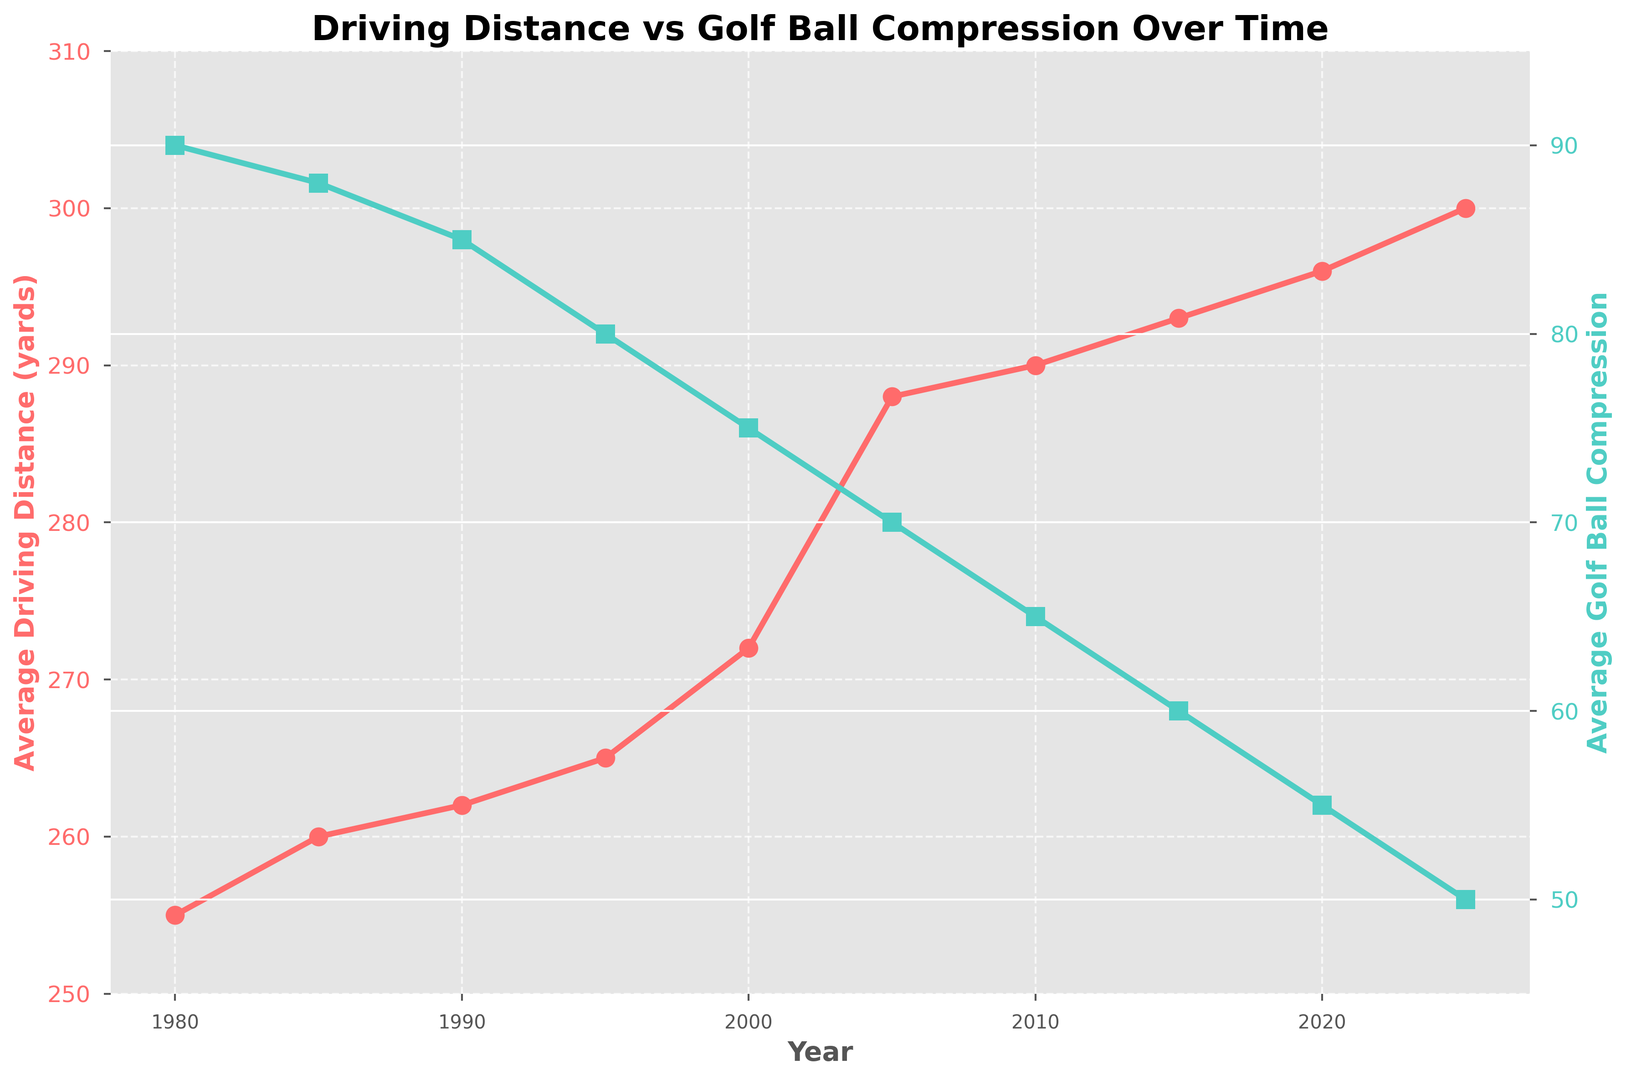What is the trend in average driving distance from 1980 to 2025? The figure shows a line plot of the average driving distance over the years. Observing the slope of the line, the driving distance consistently increases from 255 yards in 1980 to 300 yards in 2025.
Answer: Increasing What is the difference in average golf ball compression between 1980 and 2025? In 1980, the average golf ball compression is 90, and in 2025, it is 50. The difference can be calculated as 90 - 50.
Answer: 40 Which year shows the steepest increase in average driving distance? By examining the slope of the driving distance line, the steepest increase appears between 2000 and 2005, where the slope is the steepest.
Answer: 2000-2005 How does the average golf ball compression trend over time? The plot shows that the average golf ball compression decreases over time, from 90 in 1980 to 50 in 2025.
Answer: Decreasing Is there a year where both the average driving distance and the average golf ball compression increased from the previous year? By observing the curves, there are no years where both metrics increase simultaneously; one metric increases while the other decreases throughout the period.
Answer: No How much did the average driving distance increase from 2010 to 2020? The average driving distance in 2010 is 290 yards, and in 2020, it is 296 yards. The increase is calculated as 296 - 290.
Answer: 6 yards What is the visual difference between the two lines on the chart? The average driving distance line is red with circular markers, while the average golf ball compression line is green with square markers.
Answer: Red line with circular markers and green line with square markers What is the overall percentage increase in average driving distance from 1980 to 2025? The average driving distance increases from 255 yards in 1980 to 300 yards in 2025. The percentage increase can be calculated as ((300 - 255) / 255) * 100%.
Answer: 17.65% Which metric has a greater range, average driving distance or average golf ball compression? The range for driving distance is 300 - 255 = 45 yards, and the range for compression is 90 - 50 = 40.
Answer: Average driving distance 